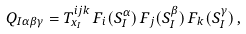Convert formula to latex. <formula><loc_0><loc_0><loc_500><loc_500>Q _ { I \alpha \beta \gamma } = T _ { x _ { I } } ^ { i j k } \, F _ { i } ( S _ { I } ^ { \alpha } ) \, F _ { j } ( S _ { I } ^ { \beta } ) \, F _ { k } ( S _ { I } ^ { \gamma } ) \, ,</formula> 